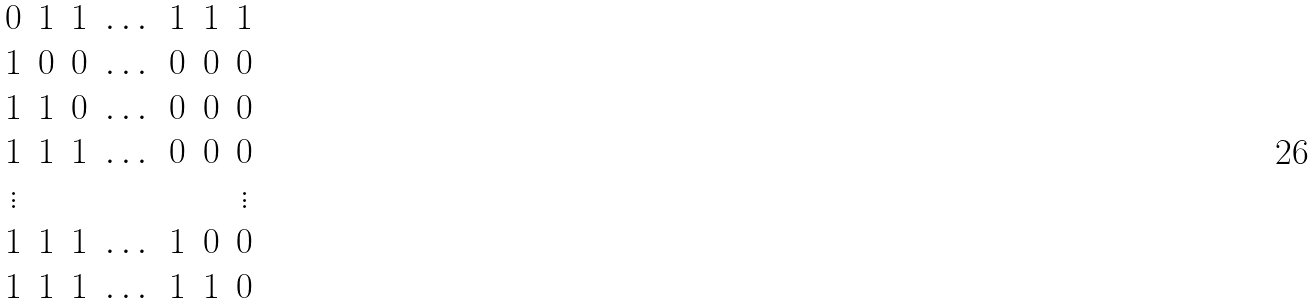Convert formula to latex. <formula><loc_0><loc_0><loc_500><loc_500>\begin{matrix} 0 & 1 & 1 & \dots & 1 & 1 & 1 \\ 1 & 0 & 0 & \dots & 0 & 0 & 0 \\ 1 & 1 & 0 & \dots & 0 & 0 & 0 \\ 1 & 1 & 1 & \dots & 0 & 0 & 0 \\ \vdots & & & & & & \vdots \\ 1 & 1 & 1 & \dots & 1 & 0 & 0 \\ 1 & 1 & 1 & \dots & 1 & 1 & 0 \\ \end{matrix}</formula> 